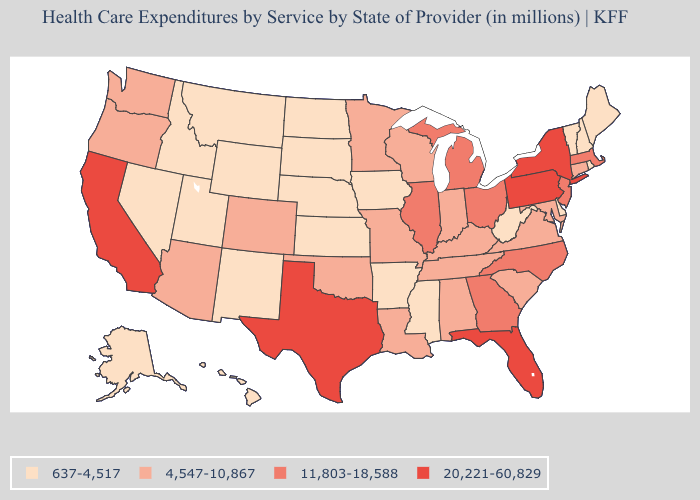Does Texas have the lowest value in the USA?
Short answer required. No. What is the value of New Mexico?
Keep it brief. 637-4,517. Does Idaho have the lowest value in the West?
Write a very short answer. Yes. What is the value of Massachusetts?
Answer briefly. 11,803-18,588. Which states have the lowest value in the USA?
Give a very brief answer. Alaska, Arkansas, Delaware, Hawaii, Idaho, Iowa, Kansas, Maine, Mississippi, Montana, Nebraska, Nevada, New Hampshire, New Mexico, North Dakota, Rhode Island, South Dakota, Utah, Vermont, West Virginia, Wyoming. What is the lowest value in states that border New Mexico?
Concise answer only. 637-4,517. Name the states that have a value in the range 20,221-60,829?
Keep it brief. California, Florida, New York, Pennsylvania, Texas. Among the states that border Delaware , does New Jersey have the lowest value?
Give a very brief answer. No. What is the value of Rhode Island?
Answer briefly. 637-4,517. Does New Jersey have a higher value than Ohio?
Be succinct. No. Does New York have the lowest value in the Northeast?
Keep it brief. No. What is the value of South Carolina?
Keep it brief. 4,547-10,867. Name the states that have a value in the range 4,547-10,867?
Short answer required. Alabama, Arizona, Colorado, Connecticut, Indiana, Kentucky, Louisiana, Maryland, Minnesota, Missouri, Oklahoma, Oregon, South Carolina, Tennessee, Virginia, Washington, Wisconsin. Name the states that have a value in the range 20,221-60,829?
Answer briefly. California, Florida, New York, Pennsylvania, Texas. Does Massachusetts have the lowest value in the USA?
Write a very short answer. No. 